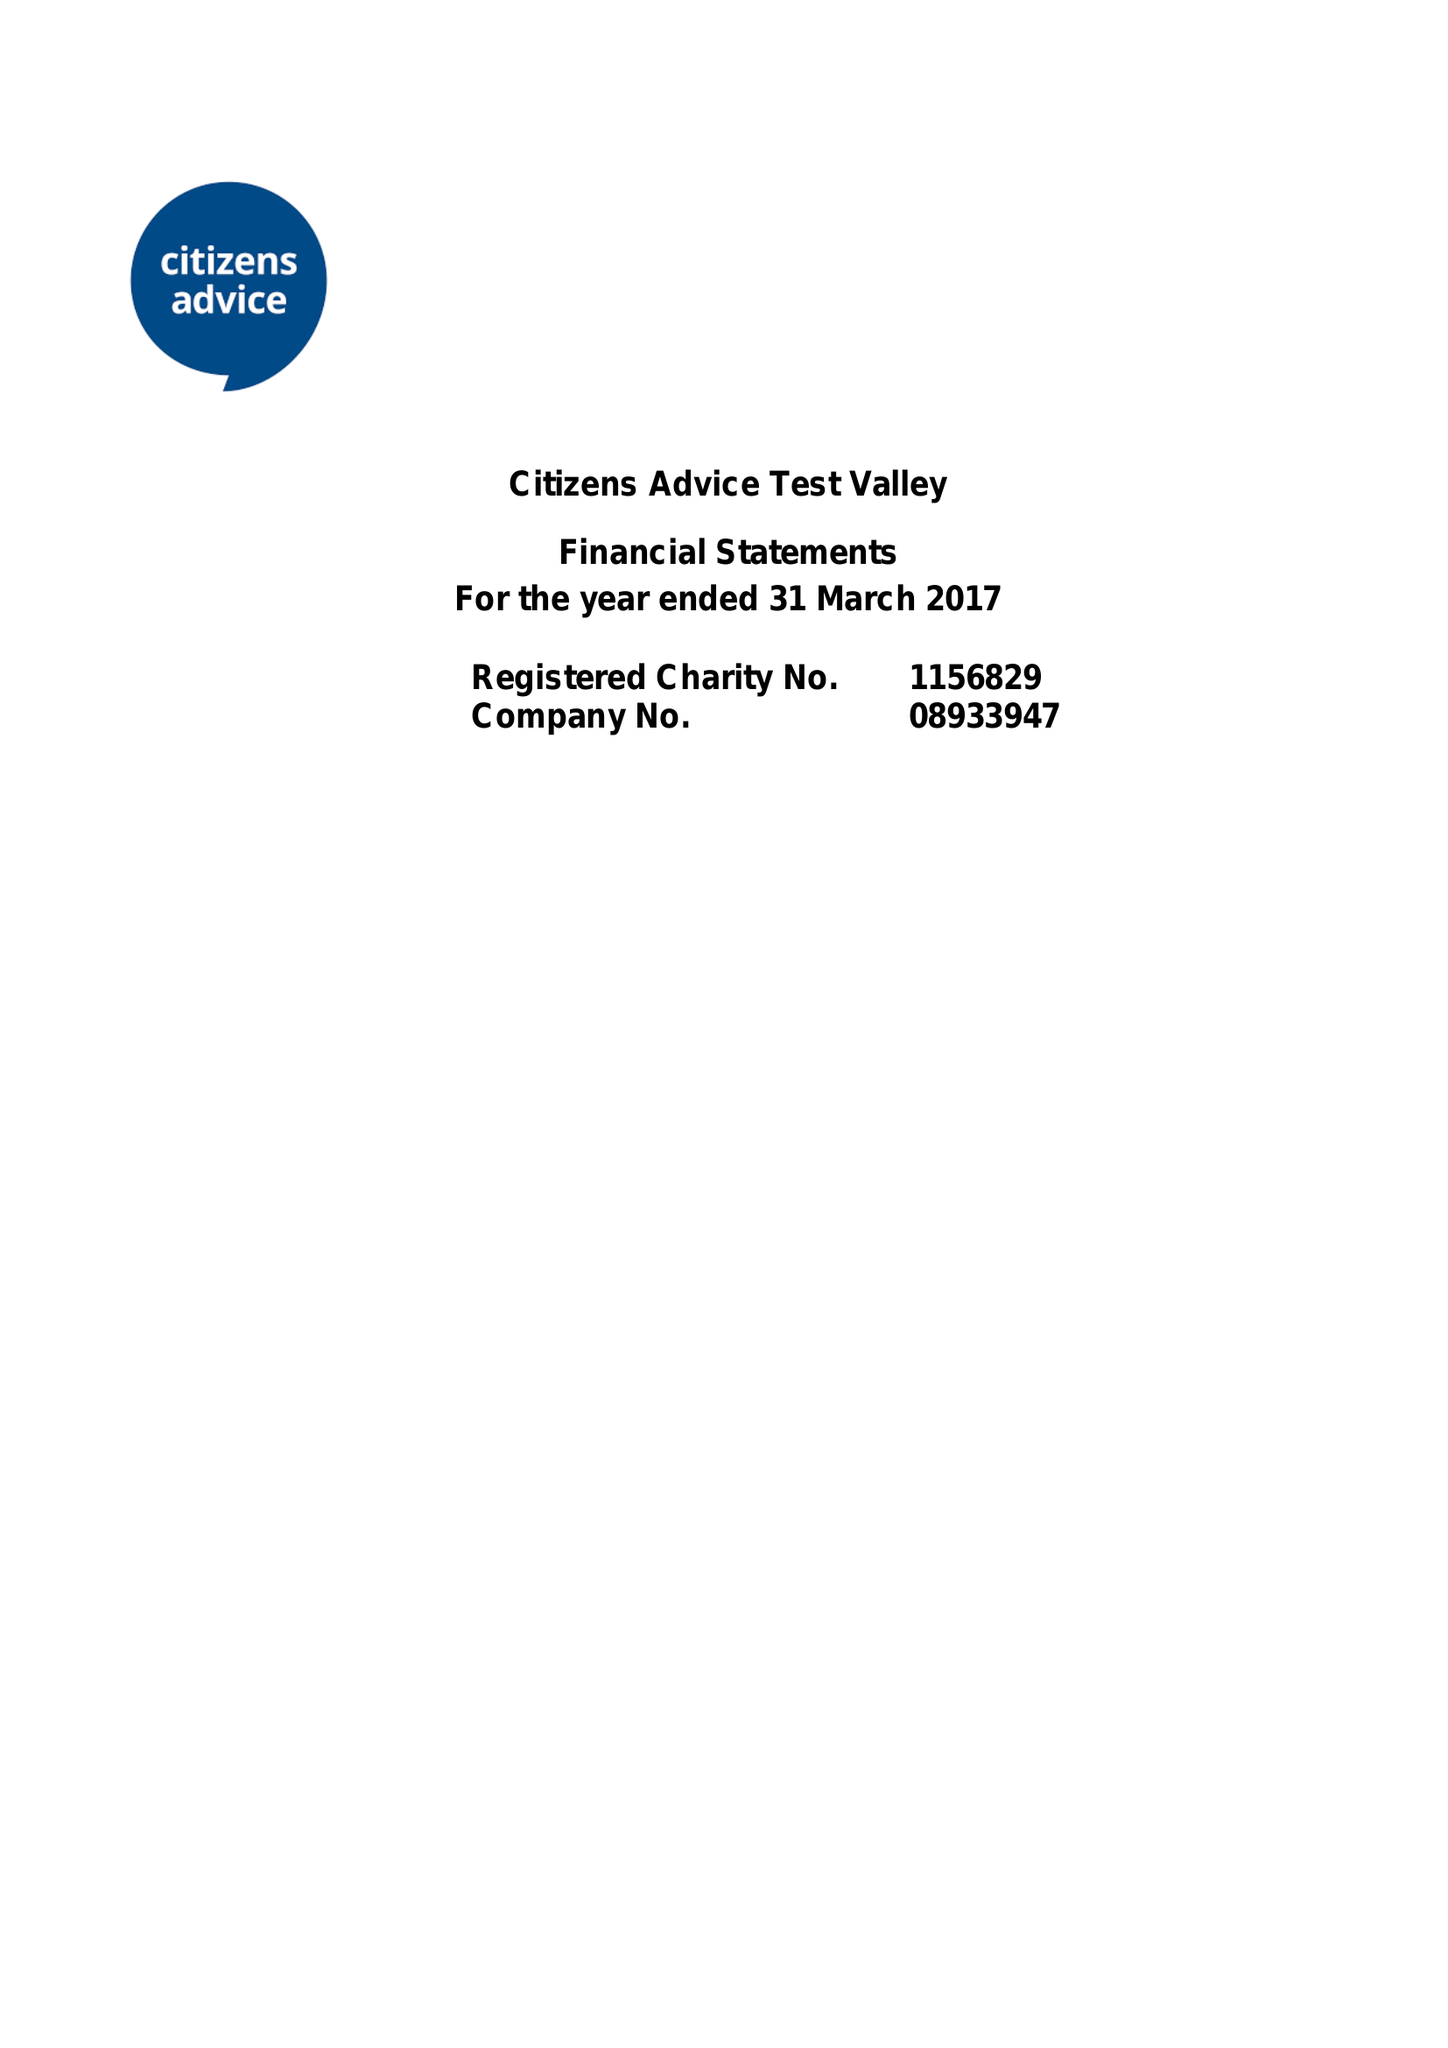What is the value for the address__postcode?
Answer the question using a single word or phrase. SP10 2NU 